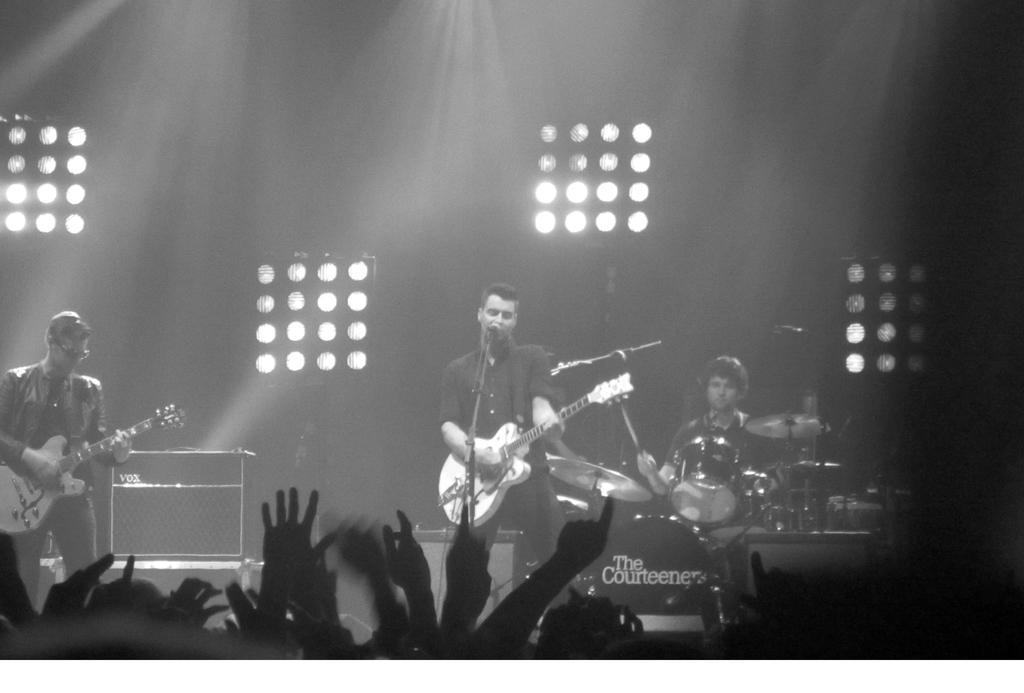Please provide a concise description of this image. In this image there are three people. The man standing on the left is playing a guitar. The man in the center is singing a song and playing a guitar, there is a mic placed before him. In the background there is a man playing a band. We can see lights. 